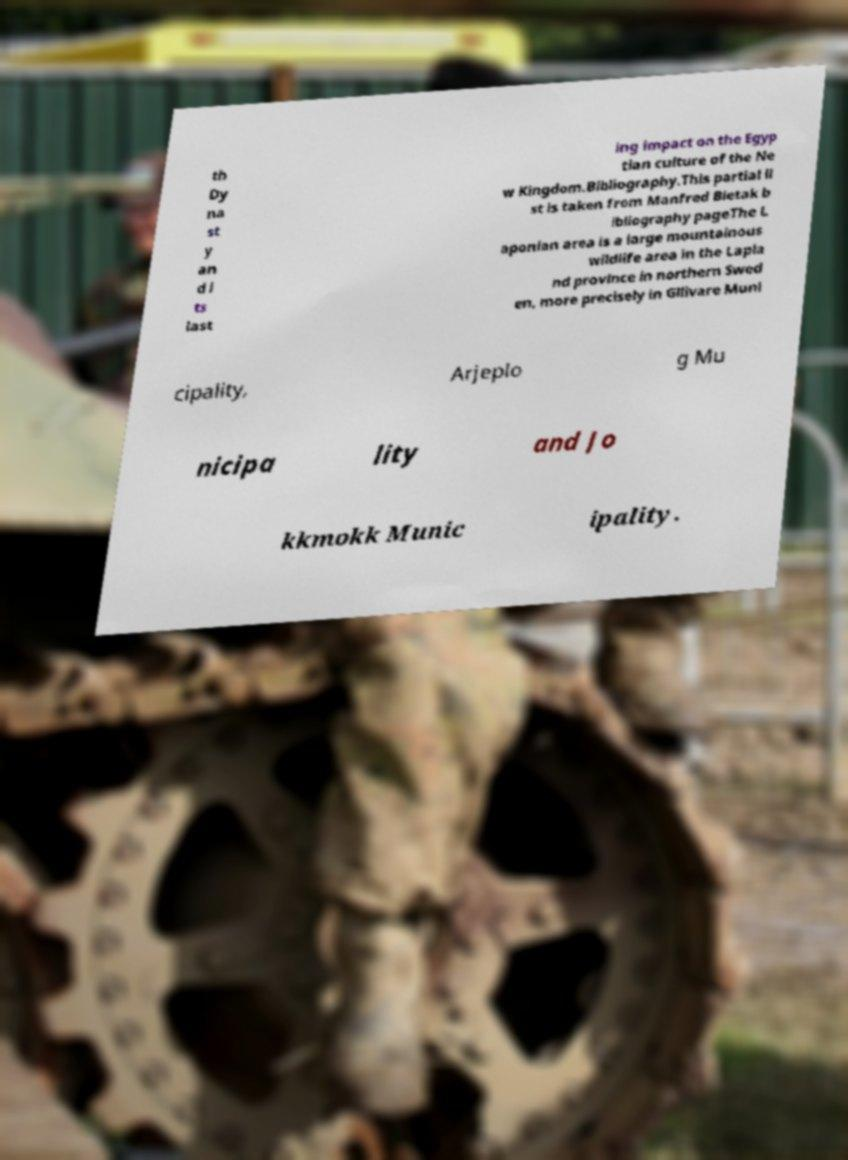Please read and relay the text visible in this image. What does it say? th Dy na st y an d i ts last ing impact on the Egyp tian culture of the Ne w Kingdom.Bibliography.This partial li st is taken from Manfred Bietak b ibliography pageThe L aponian area is a large mountainous wildlife area in the Lapla nd province in northern Swed en, more precisely in Gllivare Muni cipality, Arjeplo g Mu nicipa lity and Jo kkmokk Munic ipality. 